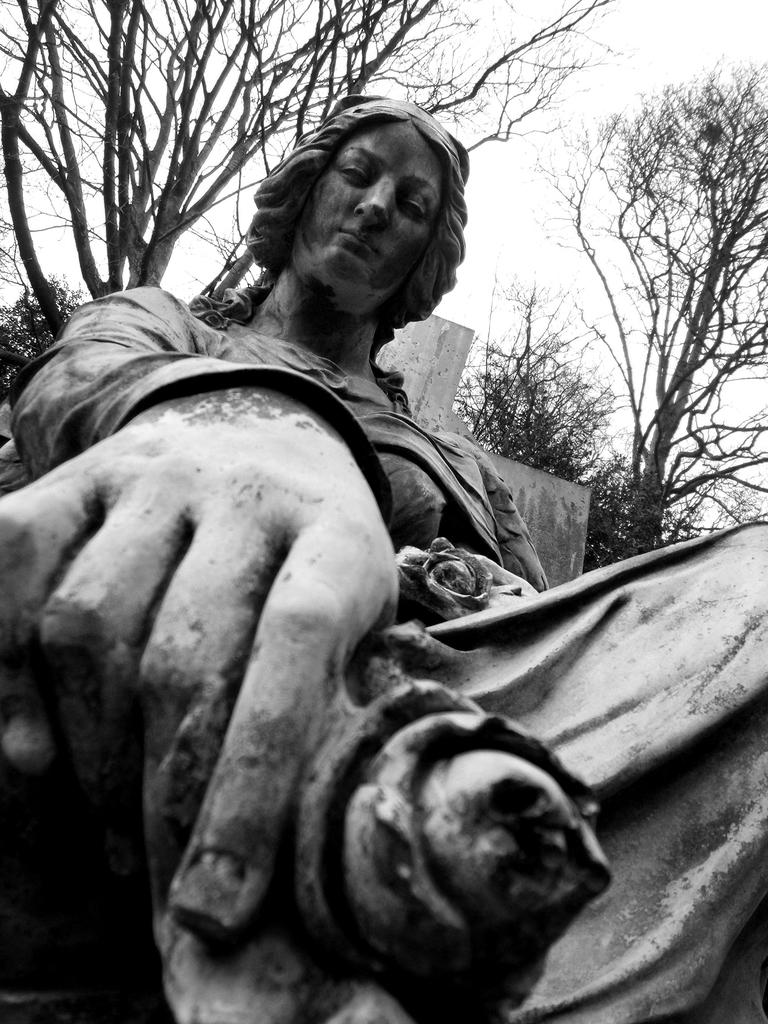What is the main subject of the image? There is a statue in the image. What can be seen in the background of the image? There are trees and the sky visible in the background of the image. What is the color scheme of the image? The image is in black and white. What type of jelly can be seen on the statue in the image? There is no jelly present on the statue in the image. Can you describe the toy that is interacting with the statue in the image? There is no toy present in the image; it only features a statue and the background. 